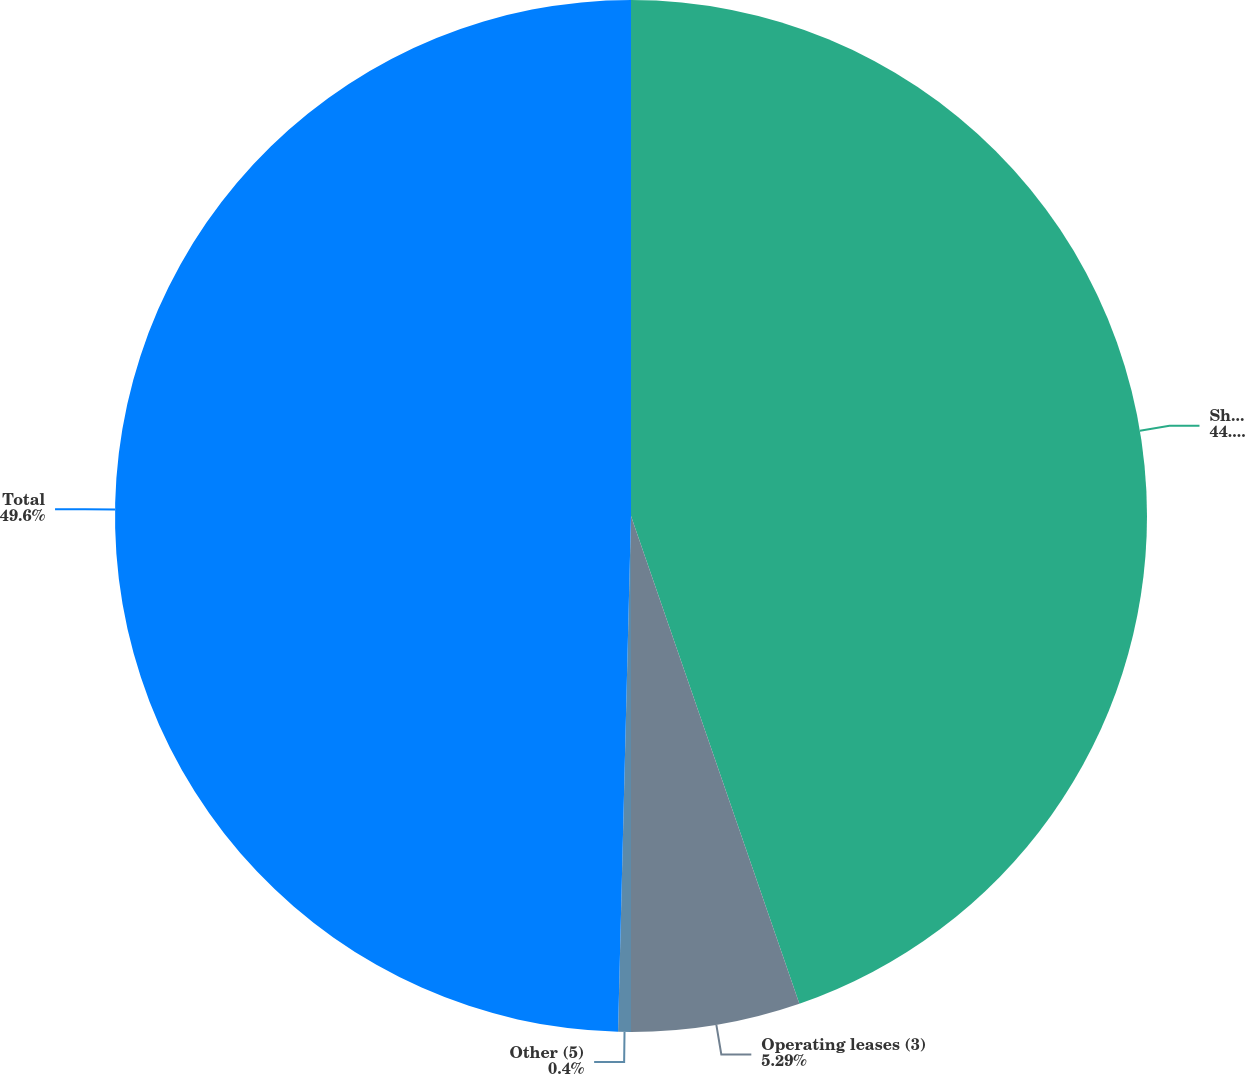Convert chart to OTSL. <chart><loc_0><loc_0><loc_500><loc_500><pie_chart><fcel>Short and long-term debt (1)<fcel>Operating leases (3)<fcel>Other (5)<fcel>Total<nl><fcel>44.71%<fcel>5.29%<fcel>0.4%<fcel>49.6%<nl></chart> 